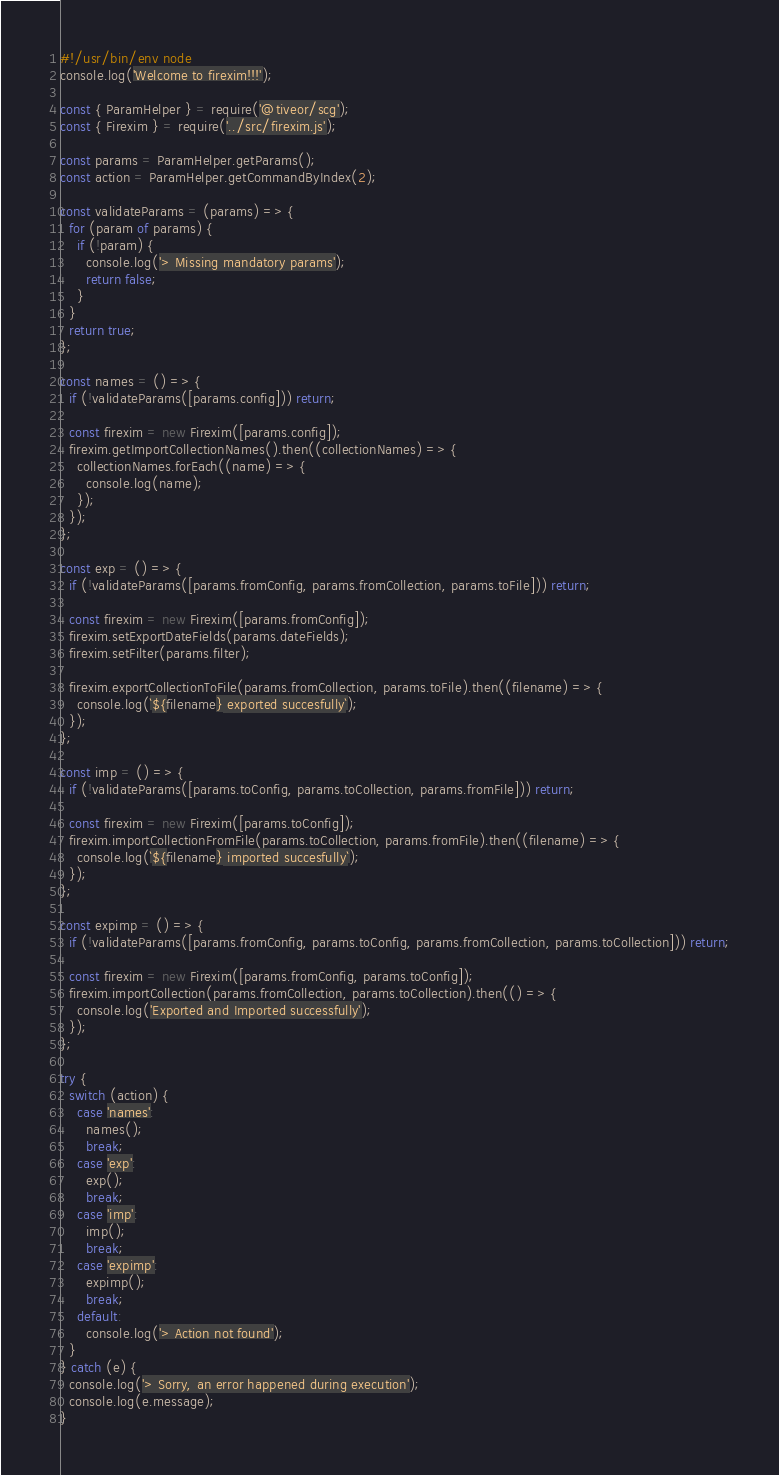<code> <loc_0><loc_0><loc_500><loc_500><_JavaScript_>#!/usr/bin/env node
console.log('Welcome to firexim!!!');

const { ParamHelper } = require('@tiveor/scg');
const { Firexim } = require('../src/firexim.js');

const params = ParamHelper.getParams();
const action = ParamHelper.getCommandByIndex(2);

const validateParams = (params) => {
  for (param of params) {
    if (!param) {
      console.log('> Missing mandatory params');
      return false;
    }
  }
  return true;
};

const names = () => {
  if (!validateParams([params.config])) return;

  const firexim = new Firexim([params.config]);
  firexim.getImportCollectionNames().then((collectionNames) => {
    collectionNames.forEach((name) => {
      console.log(name);
    });
  });
};

const exp = () => {
  if (!validateParams([params.fromConfig, params.fromCollection, params.toFile])) return;

  const firexim = new Firexim([params.fromConfig]);
  firexim.setExportDateFields(params.dateFields);
  firexim.setFilter(params.filter);

  firexim.exportCollectionToFile(params.fromCollection, params.toFile).then((filename) => {
    console.log(`${filename} exported succesfully`);
  });
};

const imp = () => {
  if (!validateParams([params.toConfig, params.toCollection, params.fromFile])) return;

  const firexim = new Firexim([params.toConfig]);
  firexim.importCollectionFromFile(params.toCollection, params.fromFile).then((filename) => {
    console.log(`${filename} imported succesfully`);
  });
};

const expimp = () => {
  if (!validateParams([params.fromConfig, params.toConfig, params.fromCollection, params.toCollection])) return;

  const firexim = new Firexim([params.fromConfig, params.toConfig]);
  firexim.importCollection(params.fromCollection, params.toCollection).then(() => {
    console.log('Exported and Imported successfully');
  });
};

try {
  switch (action) {
    case 'names':
      names();
      break;
    case 'exp':
      exp();
      break;
    case 'imp':
      imp();
      break;
    case 'expimp':
      expimp();
      break;
    default:
      console.log('> Action not found');
  }
} catch (e) {
  console.log('> Sorry, an error happened during execution');
  console.log(e.message);
}
</code> 